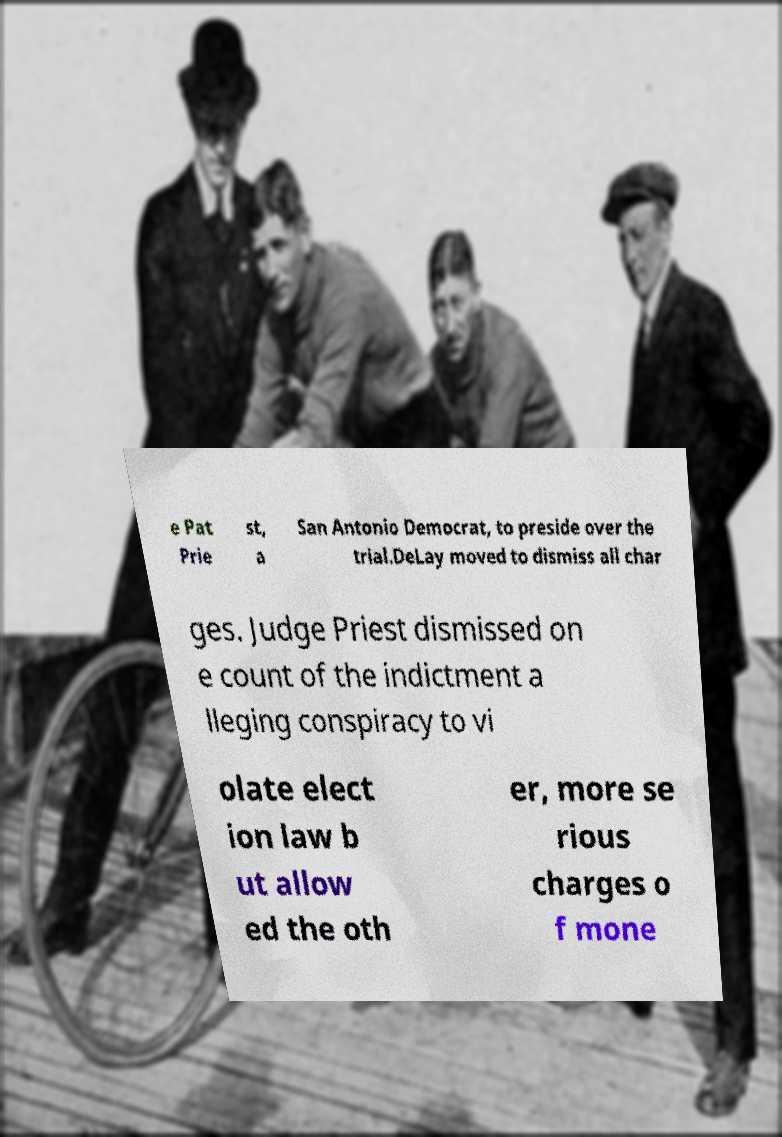I need the written content from this picture converted into text. Can you do that? e Pat Prie st, a San Antonio Democrat, to preside over the trial.DeLay moved to dismiss all char ges. Judge Priest dismissed on e count of the indictment a lleging conspiracy to vi olate elect ion law b ut allow ed the oth er, more se rious charges o f mone 